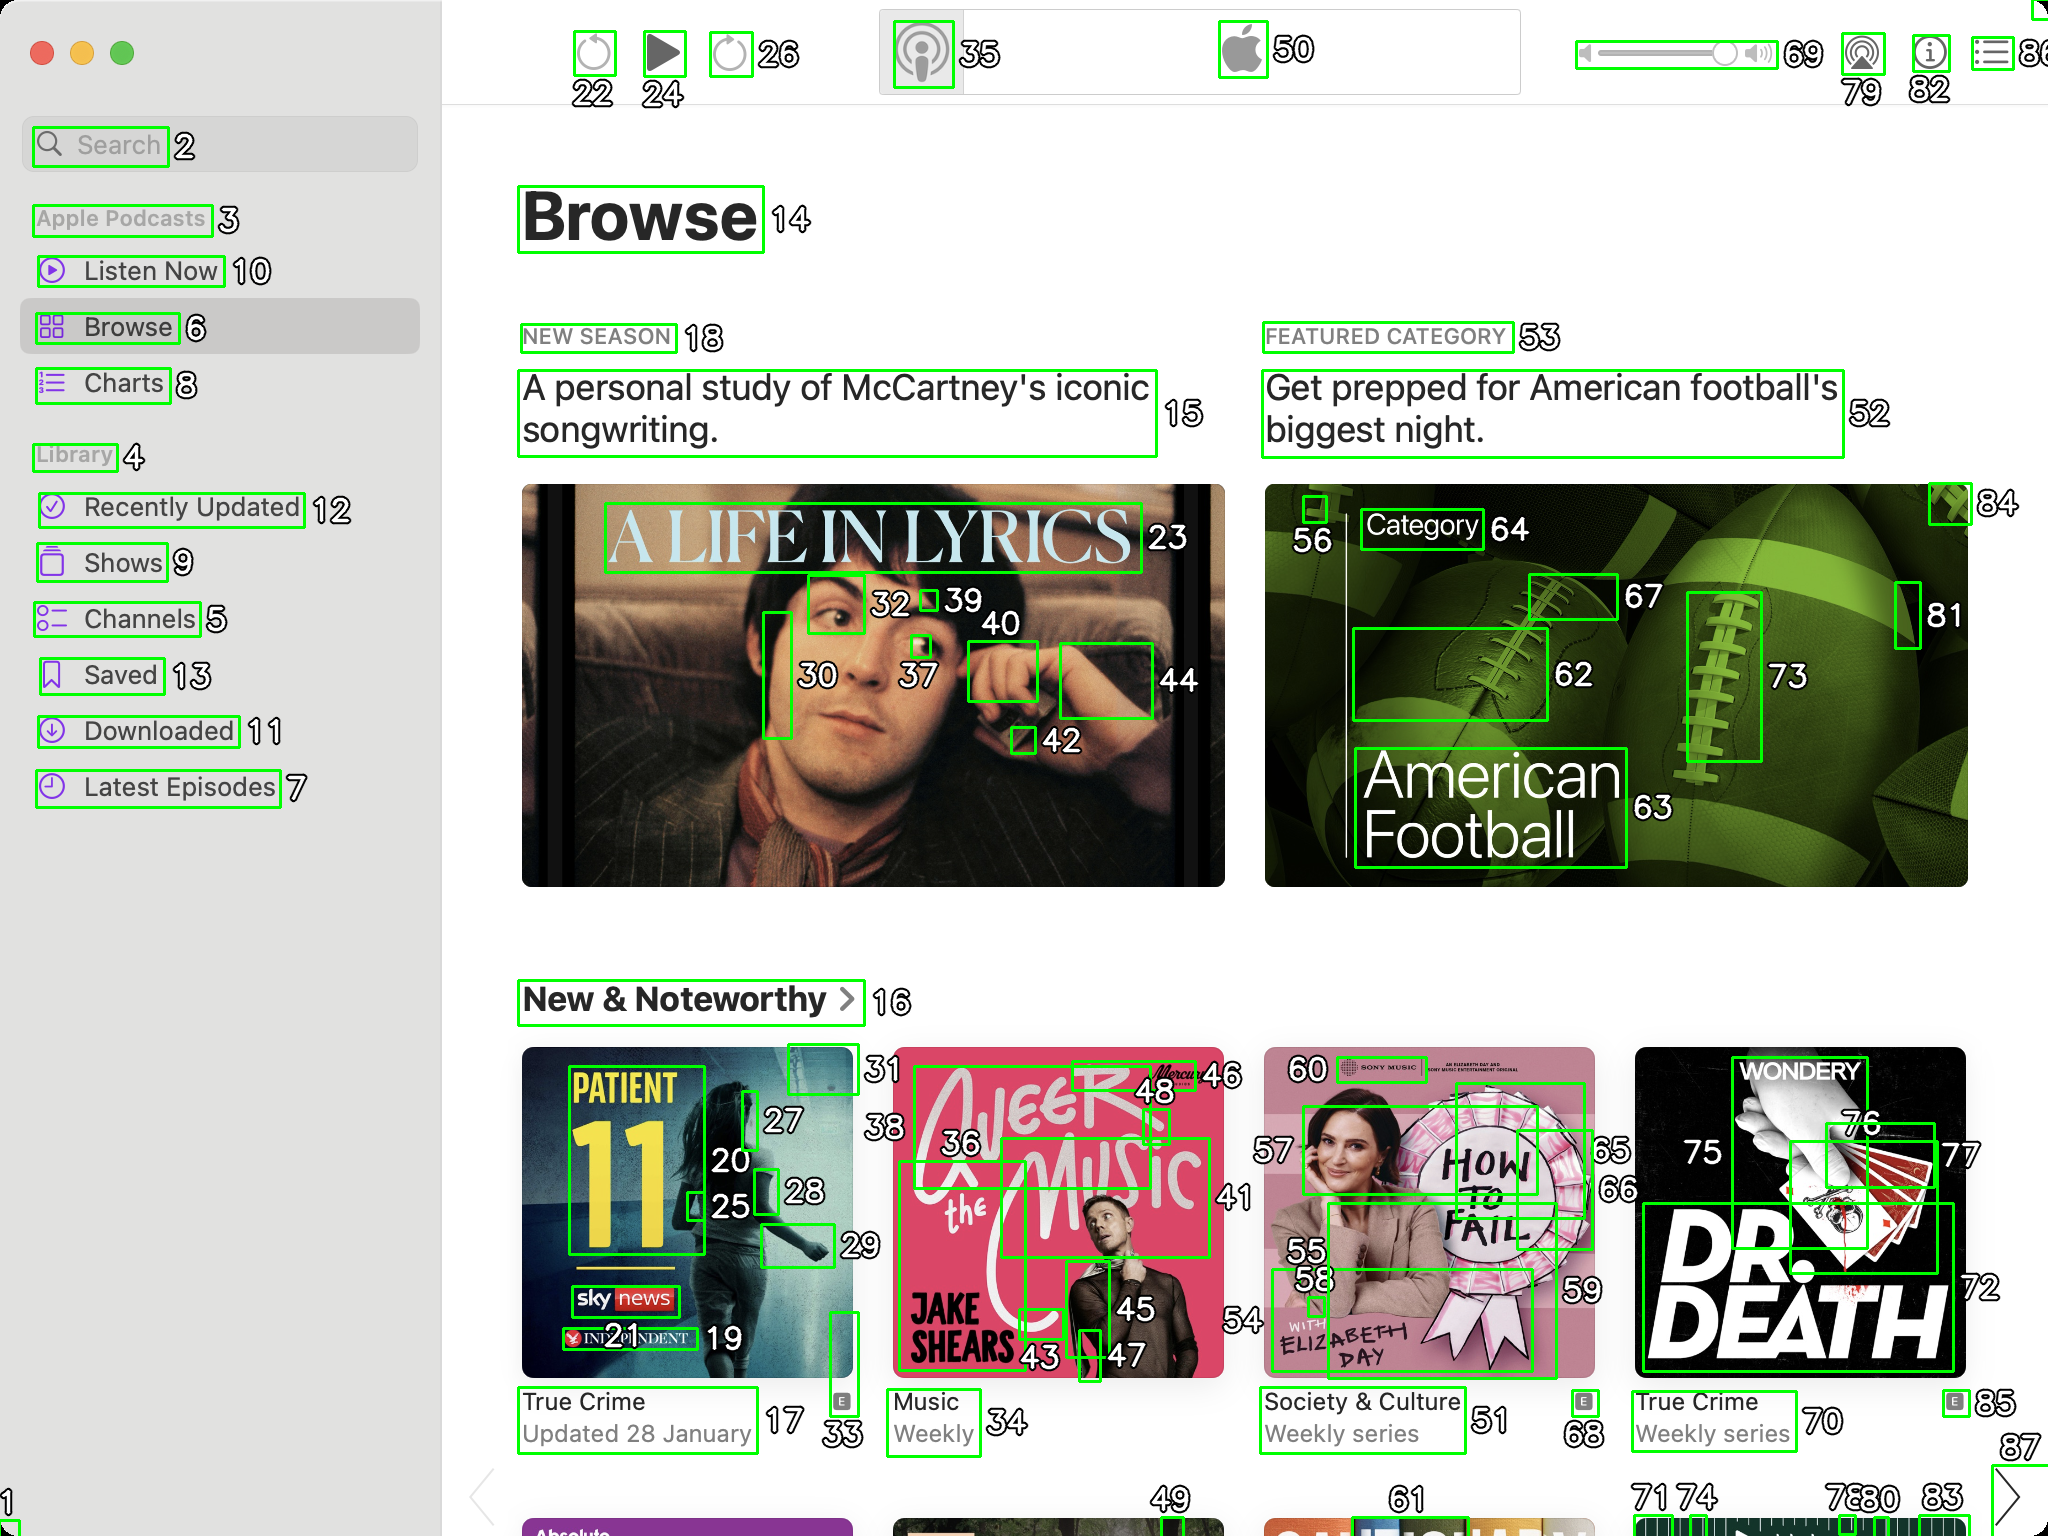You’re an expert in image processing and UI design, known for your meticulous eye when it comes to segmenting components accurately in UI screenshots. Your next task involves fixing incorrectly segmented components in UI screenshots.

Given a UI screenshot of Apple Podcasts application on MacOS with segmented components bordered in green boxes, alongside each box is an ID (a white number with a black stroke). The ID are in range 1 to 88. Some components are segmented incorrectly and need to be merged. Your task is to provide the corrected segments in JSON format.

Remember to merge only those components that are originally parts of the same entity but were wrongly split during segmentation. Keep the IDs intact to indicate the corrected grouping.

Also, analize what you have merged and give a description of what that UI component represents.

For example, if ID 5 should have included components 1, 2, 3, 4, 6, and 7 within it due to incorrect segmentation, your JSON output should be:

```json
[
	{
		"id": 5,
		"components": [1, 2, 3, 4, 6, 7],
		"description": "The podcast image"
	}
]

```

As the output provide only JSON string and nothing else. ```json
[
    {
        "id": 30,
        "components": [30, 37, 39, 42, 44],
        "description": "Podcast episode image and play button for 'A Life in Lyrics'"
    },
    {
        "id": 62,
        "components": [62, 64, 67],
        "description": "Podcast episode image and category for 'American Football'"
    },
    {
        "id": 27,
        "components": [27, 28, 33],
        "description": "Podcast episode image and play button for 'Patient 11'"
    },
    {
        "id": 36,
        "components": [36, 43, 45, 46, 48],
        "description": "Podcast episode image and play button for 'Jake the Music'"
    },
    {
        "id": 60,
        "components": [60, 55, 56, 59],
        "description": "Podcast episode image and play button for 'How to Fail'"
    },
    {
        "id": 75,
        "components": [75, 76, 77],
        "description": "Podcast episode image and play button for 'Dr. Death'"
    }
]
``` 